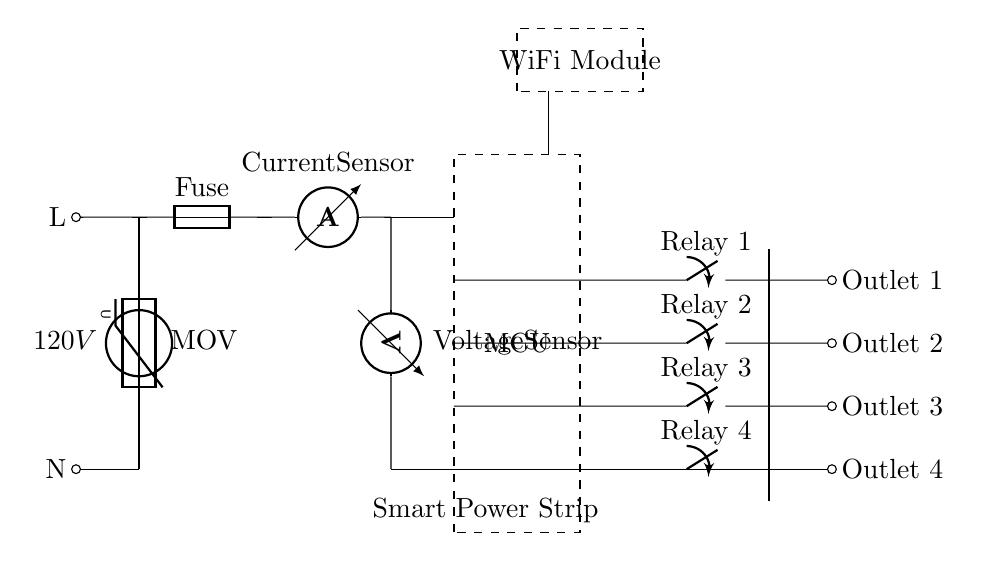What is the voltage source in this circuit? The voltage source in the circuit is labeled as 120V, which indicates the potential difference that powers the circuit.
Answer: 120V What component provides surge protection? The component responsible for surge protection in the circuit is labeled as MOV (Metal Oxide Varistor), which helps protect connected devices from voltage spikes.
Answer: MOV How many outlets does the smart power strip have? The circuit has four outlets, indicated by the four outlet labels at the end of the circuit diagram.
Answer: Four Which components are used for energy monitoring? The components used for energy monitoring are the ammeter, which measures current, and the voltmeter, which measures voltage. Both are located after the surge protection.
Answer: Ammeter and Voltmeter What is the role of the microcontroller in this circuit? The microcontroller (MCU) manages the relay controls that turn the outlets on and off based on the data gathered from the sensors. It allows the smart power strip to function intelligently according to energy usage.
Answer: Manage outlets How is the current from the power source distributed in the circuit? The current flows from the power source to the MOV for protection, then to the fuse for safety, and subsequently branches out through the outlets managed by relays, which can open or close based on the microcontroller's commands.
Answer: Through MOV, Fuse, to outlets What additional feature does the WiFi module provide? The WiFi module allows for remote monitoring and control of the power strip, enabling users to manage their appliances and monitor energy usage from a smartphone or computer.
Answer: Remote control 